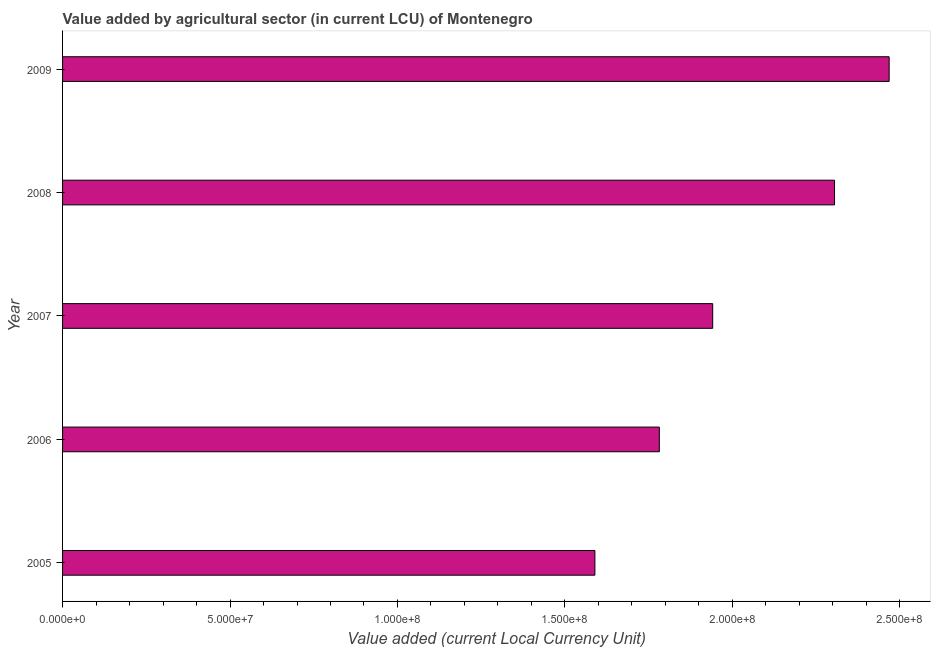What is the title of the graph?
Your answer should be very brief. Value added by agricultural sector (in current LCU) of Montenegro. What is the label or title of the X-axis?
Provide a succinct answer. Value added (current Local Currency Unit). What is the label or title of the Y-axis?
Make the answer very short. Year. What is the value added by agriculture sector in 2006?
Make the answer very short. 1.78e+08. Across all years, what is the maximum value added by agriculture sector?
Offer a very short reply. 2.47e+08. Across all years, what is the minimum value added by agriculture sector?
Your answer should be compact. 1.59e+08. In which year was the value added by agriculture sector minimum?
Ensure brevity in your answer.  2005. What is the sum of the value added by agriculture sector?
Give a very brief answer. 1.01e+09. What is the difference between the value added by agriculture sector in 2007 and 2008?
Provide a succinct answer. -3.64e+07. What is the average value added by agriculture sector per year?
Make the answer very short. 2.02e+08. What is the median value added by agriculture sector?
Provide a short and direct response. 1.94e+08. In how many years, is the value added by agriculture sector greater than 170000000 LCU?
Offer a very short reply. 4. What is the ratio of the value added by agriculture sector in 2007 to that in 2008?
Make the answer very short. 0.84. Is the difference between the value added by agriculture sector in 2006 and 2007 greater than the difference between any two years?
Provide a succinct answer. No. What is the difference between the highest and the second highest value added by agriculture sector?
Your response must be concise. 1.63e+07. What is the difference between the highest and the lowest value added by agriculture sector?
Make the answer very short. 8.79e+07. In how many years, is the value added by agriculture sector greater than the average value added by agriculture sector taken over all years?
Offer a terse response. 2. How many years are there in the graph?
Ensure brevity in your answer.  5. What is the difference between two consecutive major ticks on the X-axis?
Ensure brevity in your answer.  5.00e+07. What is the Value added (current Local Currency Unit) in 2005?
Offer a very short reply. 1.59e+08. What is the Value added (current Local Currency Unit) in 2006?
Your response must be concise. 1.78e+08. What is the Value added (current Local Currency Unit) in 2007?
Your response must be concise. 1.94e+08. What is the Value added (current Local Currency Unit) in 2008?
Offer a very short reply. 2.30e+08. What is the Value added (current Local Currency Unit) of 2009?
Offer a very short reply. 2.47e+08. What is the difference between the Value added (current Local Currency Unit) in 2005 and 2006?
Provide a short and direct response. -1.92e+07. What is the difference between the Value added (current Local Currency Unit) in 2005 and 2007?
Offer a very short reply. -3.52e+07. What is the difference between the Value added (current Local Currency Unit) in 2005 and 2008?
Offer a terse response. -7.15e+07. What is the difference between the Value added (current Local Currency Unit) in 2005 and 2009?
Make the answer very short. -8.79e+07. What is the difference between the Value added (current Local Currency Unit) in 2006 and 2007?
Your answer should be very brief. -1.59e+07. What is the difference between the Value added (current Local Currency Unit) in 2006 and 2008?
Make the answer very short. -5.23e+07. What is the difference between the Value added (current Local Currency Unit) in 2006 and 2009?
Keep it short and to the point. -6.86e+07. What is the difference between the Value added (current Local Currency Unit) in 2007 and 2008?
Your answer should be very brief. -3.64e+07. What is the difference between the Value added (current Local Currency Unit) in 2007 and 2009?
Keep it short and to the point. -5.27e+07. What is the difference between the Value added (current Local Currency Unit) in 2008 and 2009?
Your answer should be very brief. -1.63e+07. What is the ratio of the Value added (current Local Currency Unit) in 2005 to that in 2006?
Make the answer very short. 0.89. What is the ratio of the Value added (current Local Currency Unit) in 2005 to that in 2007?
Your answer should be compact. 0.82. What is the ratio of the Value added (current Local Currency Unit) in 2005 to that in 2008?
Your answer should be very brief. 0.69. What is the ratio of the Value added (current Local Currency Unit) in 2005 to that in 2009?
Provide a short and direct response. 0.64. What is the ratio of the Value added (current Local Currency Unit) in 2006 to that in 2007?
Your answer should be very brief. 0.92. What is the ratio of the Value added (current Local Currency Unit) in 2006 to that in 2008?
Offer a terse response. 0.77. What is the ratio of the Value added (current Local Currency Unit) in 2006 to that in 2009?
Offer a very short reply. 0.72. What is the ratio of the Value added (current Local Currency Unit) in 2007 to that in 2008?
Provide a short and direct response. 0.84. What is the ratio of the Value added (current Local Currency Unit) in 2007 to that in 2009?
Make the answer very short. 0.79. What is the ratio of the Value added (current Local Currency Unit) in 2008 to that in 2009?
Provide a short and direct response. 0.93. 